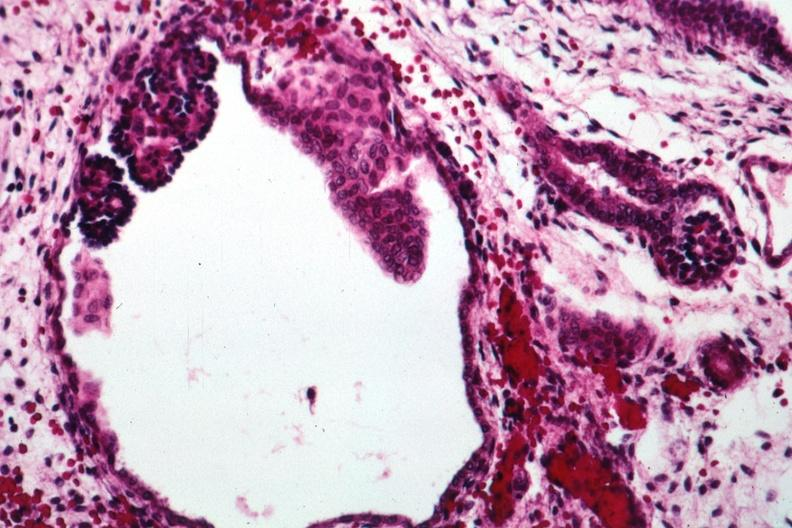what is present?
Answer the question using a single word or phrase. Kidney 